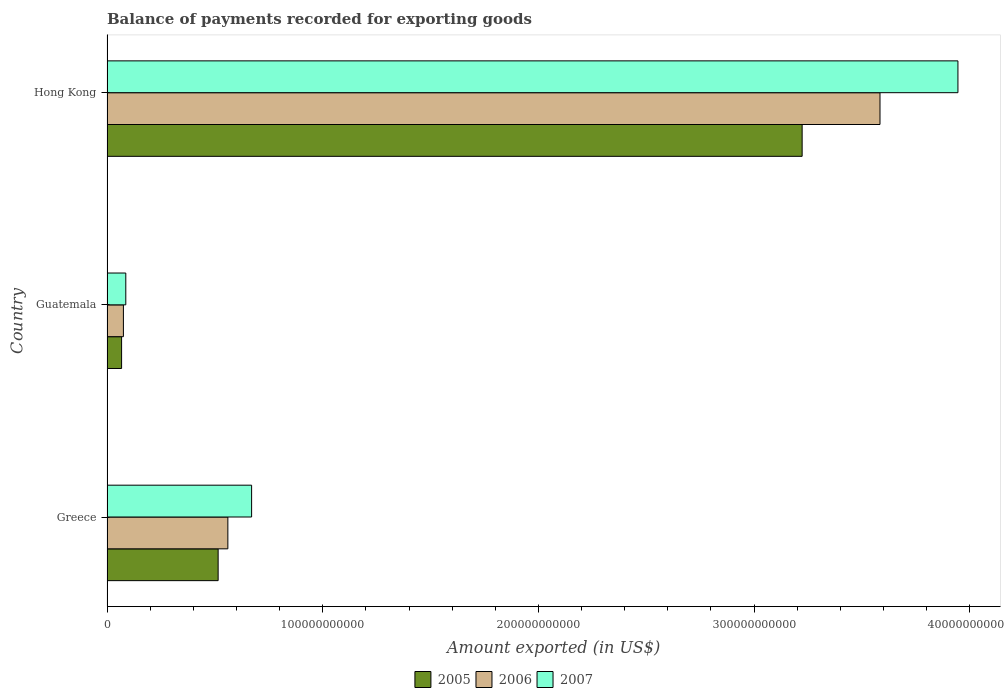How many different coloured bars are there?
Offer a very short reply. 3. Are the number of bars per tick equal to the number of legend labels?
Keep it short and to the point. Yes. Are the number of bars on each tick of the Y-axis equal?
Provide a short and direct response. Yes. What is the label of the 1st group of bars from the top?
Your answer should be very brief. Hong Kong. What is the amount exported in 2005 in Greece?
Give a very brief answer. 5.15e+1. Across all countries, what is the maximum amount exported in 2006?
Your response must be concise. 3.58e+11. Across all countries, what is the minimum amount exported in 2006?
Offer a terse response. 7.60e+09. In which country was the amount exported in 2007 maximum?
Ensure brevity in your answer.  Hong Kong. In which country was the amount exported in 2006 minimum?
Provide a succinct answer. Guatemala. What is the total amount exported in 2005 in the graph?
Ensure brevity in your answer.  3.81e+11. What is the difference between the amount exported in 2005 in Greece and that in Guatemala?
Provide a succinct answer. 4.48e+1. What is the difference between the amount exported in 2006 in Greece and the amount exported in 2007 in Guatemala?
Offer a terse response. 4.73e+1. What is the average amount exported in 2006 per country?
Keep it short and to the point. 1.41e+11. What is the difference between the amount exported in 2007 and amount exported in 2006 in Guatemala?
Provide a succinct answer. 1.11e+09. What is the ratio of the amount exported in 2007 in Greece to that in Guatemala?
Make the answer very short. 7.69. Is the amount exported in 2005 in Greece less than that in Guatemala?
Provide a succinct answer. No. What is the difference between the highest and the second highest amount exported in 2007?
Your response must be concise. 3.27e+11. What is the difference between the highest and the lowest amount exported in 2006?
Your answer should be compact. 3.51e+11. In how many countries, is the amount exported in 2006 greater than the average amount exported in 2006 taken over all countries?
Provide a short and direct response. 1. Is the sum of the amount exported in 2007 in Guatemala and Hong Kong greater than the maximum amount exported in 2006 across all countries?
Provide a succinct answer. Yes. What does the 2nd bar from the bottom in Greece represents?
Offer a very short reply. 2006. How many bars are there?
Give a very brief answer. 9. How many countries are there in the graph?
Give a very brief answer. 3. What is the difference between two consecutive major ticks on the X-axis?
Ensure brevity in your answer.  1.00e+11. Does the graph contain grids?
Your answer should be very brief. No. Where does the legend appear in the graph?
Your answer should be compact. Bottom center. How many legend labels are there?
Give a very brief answer. 3. How are the legend labels stacked?
Make the answer very short. Horizontal. What is the title of the graph?
Offer a very short reply. Balance of payments recorded for exporting goods. Does "1968" appear as one of the legend labels in the graph?
Your response must be concise. No. What is the label or title of the X-axis?
Keep it short and to the point. Amount exported (in US$). What is the label or title of the Y-axis?
Ensure brevity in your answer.  Country. What is the Amount exported (in US$) of 2005 in Greece?
Offer a very short reply. 5.15e+1. What is the Amount exported (in US$) in 2006 in Greece?
Offer a terse response. 5.60e+1. What is the Amount exported (in US$) in 2007 in Greece?
Your response must be concise. 6.70e+1. What is the Amount exported (in US$) of 2005 in Guatemala?
Ensure brevity in your answer.  6.77e+09. What is the Amount exported (in US$) in 2006 in Guatemala?
Provide a succinct answer. 7.60e+09. What is the Amount exported (in US$) of 2007 in Guatemala?
Give a very brief answer. 8.71e+09. What is the Amount exported (in US$) of 2005 in Hong Kong?
Your answer should be very brief. 3.22e+11. What is the Amount exported (in US$) of 2006 in Hong Kong?
Offer a terse response. 3.58e+11. What is the Amount exported (in US$) of 2007 in Hong Kong?
Your answer should be compact. 3.94e+11. Across all countries, what is the maximum Amount exported (in US$) in 2005?
Ensure brevity in your answer.  3.22e+11. Across all countries, what is the maximum Amount exported (in US$) in 2006?
Ensure brevity in your answer.  3.58e+11. Across all countries, what is the maximum Amount exported (in US$) in 2007?
Your response must be concise. 3.94e+11. Across all countries, what is the minimum Amount exported (in US$) of 2005?
Keep it short and to the point. 6.77e+09. Across all countries, what is the minimum Amount exported (in US$) in 2006?
Offer a terse response. 7.60e+09. Across all countries, what is the minimum Amount exported (in US$) of 2007?
Your answer should be very brief. 8.71e+09. What is the total Amount exported (in US$) of 2005 in the graph?
Your answer should be compact. 3.81e+11. What is the total Amount exported (in US$) of 2006 in the graph?
Give a very brief answer. 4.22e+11. What is the total Amount exported (in US$) in 2007 in the graph?
Offer a terse response. 4.70e+11. What is the difference between the Amount exported (in US$) in 2005 in Greece and that in Guatemala?
Offer a terse response. 4.48e+1. What is the difference between the Amount exported (in US$) in 2006 in Greece and that in Guatemala?
Provide a succinct answer. 4.84e+1. What is the difference between the Amount exported (in US$) in 2007 in Greece and that in Guatemala?
Provide a succinct answer. 5.83e+1. What is the difference between the Amount exported (in US$) of 2005 in Greece and that in Hong Kong?
Offer a terse response. -2.71e+11. What is the difference between the Amount exported (in US$) in 2006 in Greece and that in Hong Kong?
Keep it short and to the point. -3.02e+11. What is the difference between the Amount exported (in US$) of 2007 in Greece and that in Hong Kong?
Keep it short and to the point. -3.27e+11. What is the difference between the Amount exported (in US$) in 2005 in Guatemala and that in Hong Kong?
Your response must be concise. -3.15e+11. What is the difference between the Amount exported (in US$) in 2006 in Guatemala and that in Hong Kong?
Keep it short and to the point. -3.51e+11. What is the difference between the Amount exported (in US$) in 2007 in Guatemala and that in Hong Kong?
Offer a terse response. -3.86e+11. What is the difference between the Amount exported (in US$) of 2005 in Greece and the Amount exported (in US$) of 2006 in Guatemala?
Provide a short and direct response. 4.39e+1. What is the difference between the Amount exported (in US$) in 2005 in Greece and the Amount exported (in US$) in 2007 in Guatemala?
Your response must be concise. 4.28e+1. What is the difference between the Amount exported (in US$) of 2006 in Greece and the Amount exported (in US$) of 2007 in Guatemala?
Ensure brevity in your answer.  4.73e+1. What is the difference between the Amount exported (in US$) of 2005 in Greece and the Amount exported (in US$) of 2006 in Hong Kong?
Provide a succinct answer. -3.07e+11. What is the difference between the Amount exported (in US$) in 2005 in Greece and the Amount exported (in US$) in 2007 in Hong Kong?
Provide a succinct answer. -3.43e+11. What is the difference between the Amount exported (in US$) of 2006 in Greece and the Amount exported (in US$) of 2007 in Hong Kong?
Ensure brevity in your answer.  -3.38e+11. What is the difference between the Amount exported (in US$) in 2005 in Guatemala and the Amount exported (in US$) in 2006 in Hong Kong?
Your answer should be very brief. -3.52e+11. What is the difference between the Amount exported (in US$) in 2005 in Guatemala and the Amount exported (in US$) in 2007 in Hong Kong?
Provide a short and direct response. -3.88e+11. What is the difference between the Amount exported (in US$) of 2006 in Guatemala and the Amount exported (in US$) of 2007 in Hong Kong?
Your response must be concise. -3.87e+11. What is the average Amount exported (in US$) of 2005 per country?
Keep it short and to the point. 1.27e+11. What is the average Amount exported (in US$) of 2006 per country?
Provide a short and direct response. 1.41e+11. What is the average Amount exported (in US$) in 2007 per country?
Keep it short and to the point. 1.57e+11. What is the difference between the Amount exported (in US$) of 2005 and Amount exported (in US$) of 2006 in Greece?
Give a very brief answer. -4.51e+09. What is the difference between the Amount exported (in US$) in 2005 and Amount exported (in US$) in 2007 in Greece?
Your response must be concise. -1.55e+1. What is the difference between the Amount exported (in US$) of 2006 and Amount exported (in US$) of 2007 in Greece?
Provide a succinct answer. -1.10e+1. What is the difference between the Amount exported (in US$) in 2005 and Amount exported (in US$) in 2006 in Guatemala?
Offer a terse response. -8.34e+08. What is the difference between the Amount exported (in US$) in 2005 and Amount exported (in US$) in 2007 in Guatemala?
Your answer should be compact. -1.95e+09. What is the difference between the Amount exported (in US$) of 2006 and Amount exported (in US$) of 2007 in Guatemala?
Give a very brief answer. -1.11e+09. What is the difference between the Amount exported (in US$) of 2005 and Amount exported (in US$) of 2006 in Hong Kong?
Provide a succinct answer. -3.61e+1. What is the difference between the Amount exported (in US$) in 2005 and Amount exported (in US$) in 2007 in Hong Kong?
Your answer should be very brief. -7.22e+1. What is the difference between the Amount exported (in US$) in 2006 and Amount exported (in US$) in 2007 in Hong Kong?
Ensure brevity in your answer.  -3.61e+1. What is the ratio of the Amount exported (in US$) of 2005 in Greece to that in Guatemala?
Offer a terse response. 7.61. What is the ratio of the Amount exported (in US$) of 2006 in Greece to that in Guatemala?
Your answer should be very brief. 7.37. What is the ratio of the Amount exported (in US$) in 2007 in Greece to that in Guatemala?
Provide a succinct answer. 7.69. What is the ratio of the Amount exported (in US$) in 2005 in Greece to that in Hong Kong?
Your answer should be very brief. 0.16. What is the ratio of the Amount exported (in US$) in 2006 in Greece to that in Hong Kong?
Your answer should be compact. 0.16. What is the ratio of the Amount exported (in US$) of 2007 in Greece to that in Hong Kong?
Your answer should be compact. 0.17. What is the ratio of the Amount exported (in US$) in 2005 in Guatemala to that in Hong Kong?
Your response must be concise. 0.02. What is the ratio of the Amount exported (in US$) of 2006 in Guatemala to that in Hong Kong?
Ensure brevity in your answer.  0.02. What is the ratio of the Amount exported (in US$) in 2007 in Guatemala to that in Hong Kong?
Provide a succinct answer. 0.02. What is the difference between the highest and the second highest Amount exported (in US$) in 2005?
Your response must be concise. 2.71e+11. What is the difference between the highest and the second highest Amount exported (in US$) of 2006?
Keep it short and to the point. 3.02e+11. What is the difference between the highest and the second highest Amount exported (in US$) of 2007?
Keep it short and to the point. 3.27e+11. What is the difference between the highest and the lowest Amount exported (in US$) of 2005?
Your answer should be compact. 3.15e+11. What is the difference between the highest and the lowest Amount exported (in US$) in 2006?
Give a very brief answer. 3.51e+11. What is the difference between the highest and the lowest Amount exported (in US$) of 2007?
Your answer should be compact. 3.86e+11. 